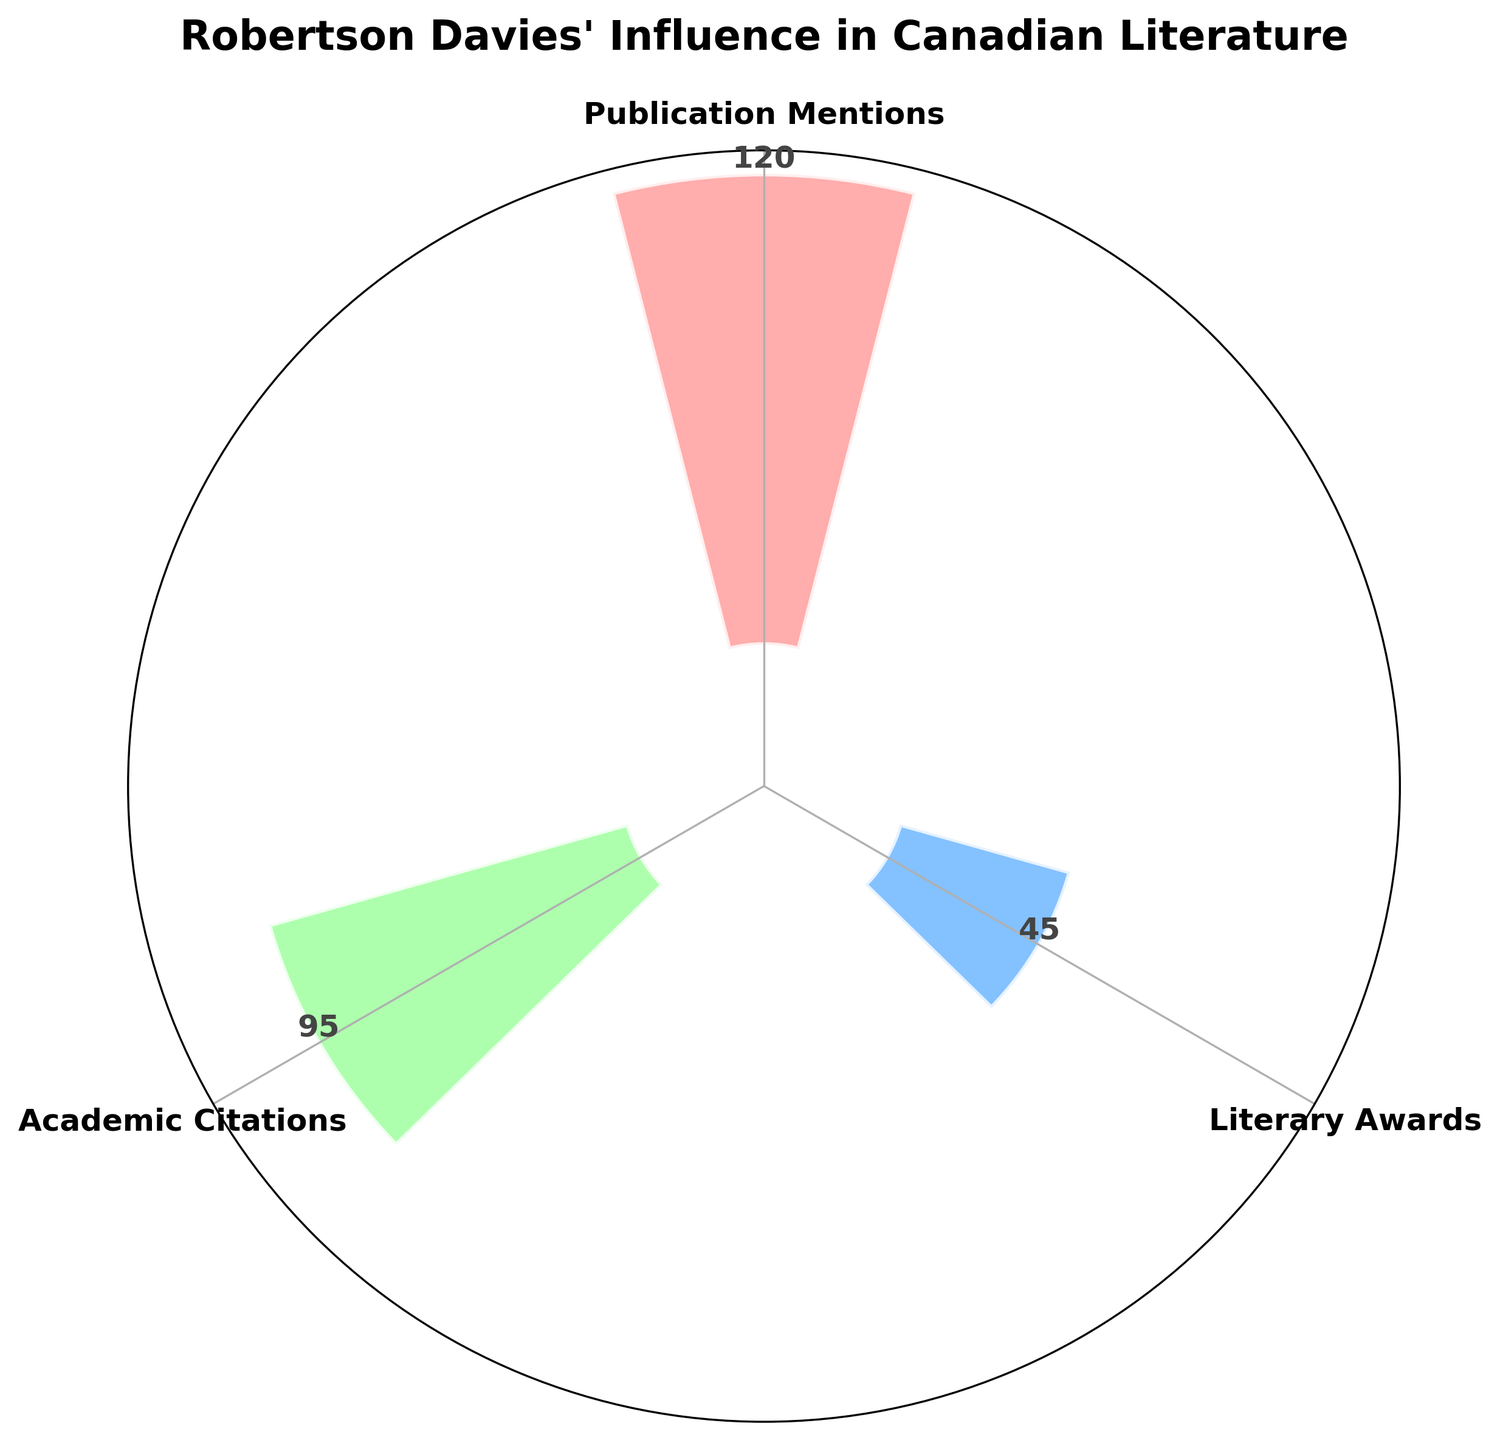What is the title of the plot? The title is displayed on top of the plot and reads "Robertson Davies' Influence in Canadian Literature." This title clearly suggests the thematic context of the data.
Answer: Robertson Davies' Influence in Canadian Literature How many categories are represented in the plot? The plot shows 3 distinct bars, each representing a different category labeled on the x-axis.
Answer: 3 What color is used for the 'Literary Awards' category? The 'Literary Awards' bar is colored with a light blue shade, different from the other categories, making it distinguishable.
Answer: Light blue Which category has the highest number of mentions? The height of the 'Publication Mentions' bar is the highest among the three categories, indicating it has the most mentions.
Answer: Publication Mentions How many more mentions do 'Publication Mentions' have compared to 'Literary Awards'? To find this, subtract the number of mentions for 'Literary Awards' (45) from the 'Publication Mentions' (120). Therefore, 120 - 45 = 75.
Answer: 75 What is the average number of mentions across all categories? To calculate the average, sum the number of mentions for all categories (120 + 45 + 95 = 260) and then divide by the number of categories (3). Thus, 260/3 ≈ 86.67.
Answer: 86.67 Which direction does the plot start measuring from? The theta direction indicator shows that measurement starts from the top, labeled 'N'. This is indicated by the 'theta zero direction' setting pointing north.
Answer: North Which category has the smallest number of mentions, and how many does it have? The shortest bar corresponds to the 'Literary Awards' category, indicating it has the fewest mentions at 45.
Answer: Literary Awards, 45 How does the plot visually differentiate between different categories? The bars are distinctly colored and labeled, using shades of pink, blue, and green to represent 'Publication Mentions', 'Literary Awards', and 'Academic Citations', respectively. This differentiation is further reinforced by their respective heights.
Answer: Color and height 